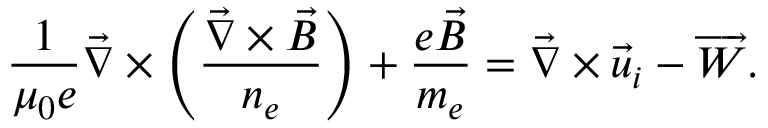Convert formula to latex. <formula><loc_0><loc_0><loc_500><loc_500>\frac { 1 } { \mu _ { 0 } e } \vec { \nabla } \times \left ( \frac { \vec { \nabla } \times \vec { B } } { n _ { e } } \right ) + \frac { e \vec { B } } { m _ { e } } = \vec { \nabla } \times \vec { u } _ { i } - \overrightarrow { W } .</formula> 